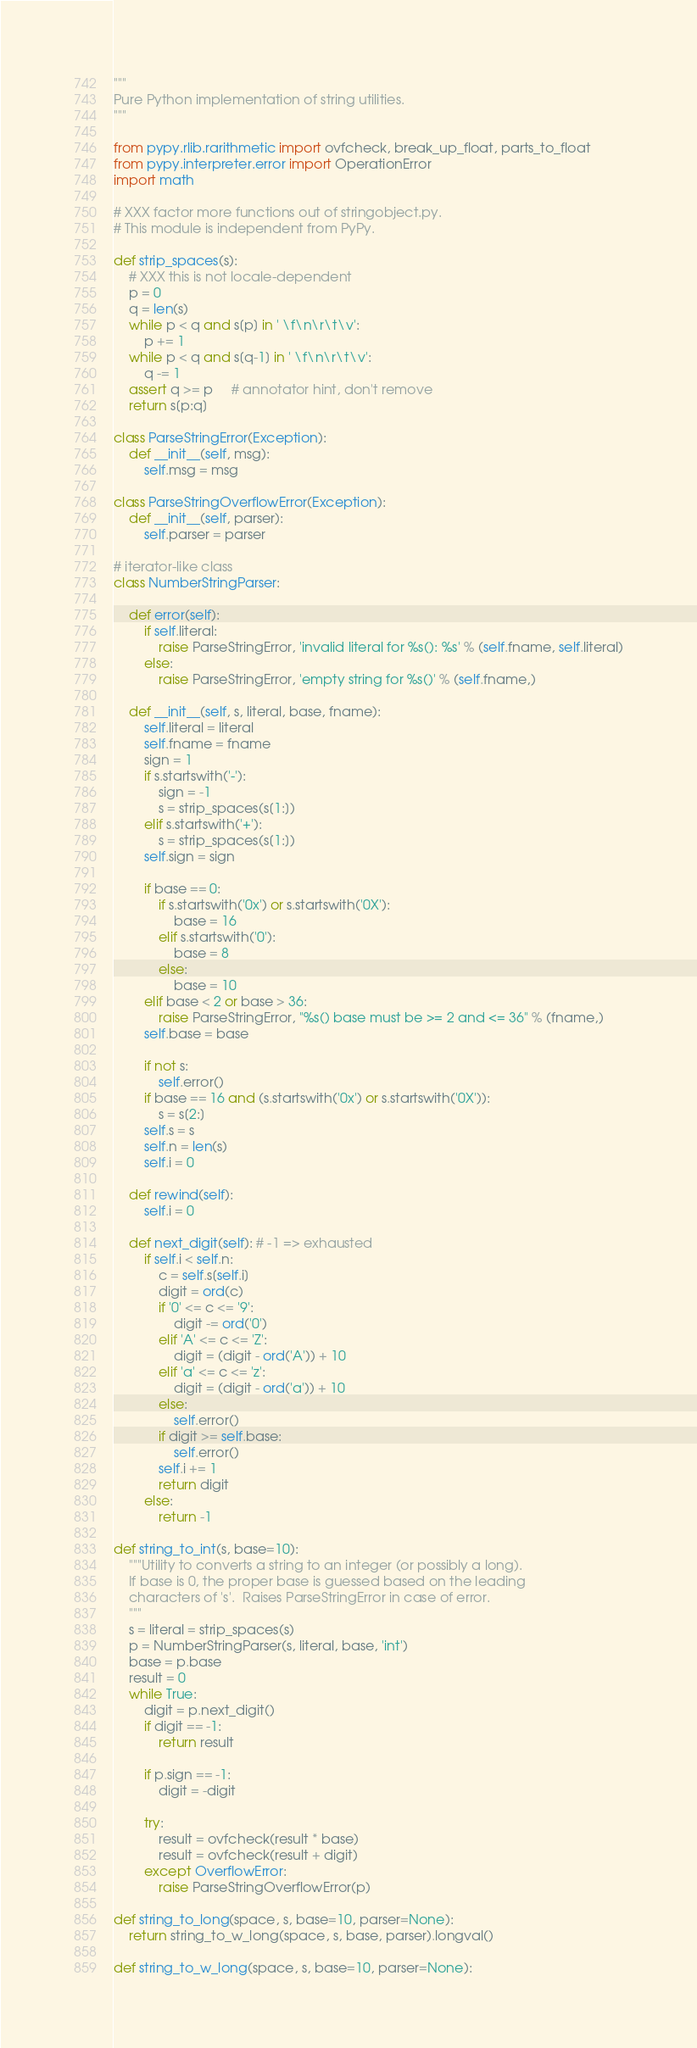Convert code to text. <code><loc_0><loc_0><loc_500><loc_500><_Python_>"""
Pure Python implementation of string utilities.
"""

from pypy.rlib.rarithmetic import ovfcheck, break_up_float, parts_to_float
from pypy.interpreter.error import OperationError
import math

# XXX factor more functions out of stringobject.py.
# This module is independent from PyPy.

def strip_spaces(s):
    # XXX this is not locale-dependent
    p = 0
    q = len(s)
    while p < q and s[p] in ' \f\n\r\t\v':
        p += 1
    while p < q and s[q-1] in ' \f\n\r\t\v':
        q -= 1
    assert q >= p     # annotator hint, don't remove
    return s[p:q]

class ParseStringError(Exception):
    def __init__(self, msg):
        self.msg = msg

class ParseStringOverflowError(Exception):
    def __init__(self, parser):
        self.parser = parser

# iterator-like class
class NumberStringParser:

    def error(self):
        if self.literal:
            raise ParseStringError, 'invalid literal for %s(): %s' % (self.fname, self.literal)
        else:
            raise ParseStringError, 'empty string for %s()' % (self.fname,)        
        
    def __init__(self, s, literal, base, fname):
        self.literal = literal
        self.fname = fname
        sign = 1
        if s.startswith('-'):
            sign = -1
            s = strip_spaces(s[1:])
        elif s.startswith('+'):
            s = strip_spaces(s[1:])
        self.sign = sign
        
        if base == 0:
            if s.startswith('0x') or s.startswith('0X'):
                base = 16
            elif s.startswith('0'):
                base = 8
            else:
                base = 10
        elif base < 2 or base > 36:
            raise ParseStringError, "%s() base must be >= 2 and <= 36" % (fname,)
        self.base = base

        if not s:
            self.error()
        if base == 16 and (s.startswith('0x') or s.startswith('0X')):
            s = s[2:]
        self.s = s
        self.n = len(s)
        self.i = 0

    def rewind(self):
        self.i = 0

    def next_digit(self): # -1 => exhausted
        if self.i < self.n:
            c = self.s[self.i]
            digit = ord(c)
            if '0' <= c <= '9':
                digit -= ord('0')
            elif 'A' <= c <= 'Z':
                digit = (digit - ord('A')) + 10
            elif 'a' <= c <= 'z':
                digit = (digit - ord('a')) + 10
            else:
                self.error()
            if digit >= self.base:
                self.error()
            self.i += 1
            return digit
        else:
            return -1

def string_to_int(s, base=10):
    """Utility to converts a string to an integer (or possibly a long).
    If base is 0, the proper base is guessed based on the leading
    characters of 's'.  Raises ParseStringError in case of error.
    """
    s = literal = strip_spaces(s)
    p = NumberStringParser(s, literal, base, 'int')
    base = p.base
    result = 0
    while True:
        digit = p.next_digit()
        if digit == -1:
            return result

        if p.sign == -1:
            digit = -digit

        try:
            result = ovfcheck(result * base)
            result = ovfcheck(result + digit)
        except OverflowError:
            raise ParseStringOverflowError(p)

def string_to_long(space, s, base=10, parser=None):
    return string_to_w_long(space, s, base, parser).longval()

def string_to_w_long(space, s, base=10, parser=None):</code> 